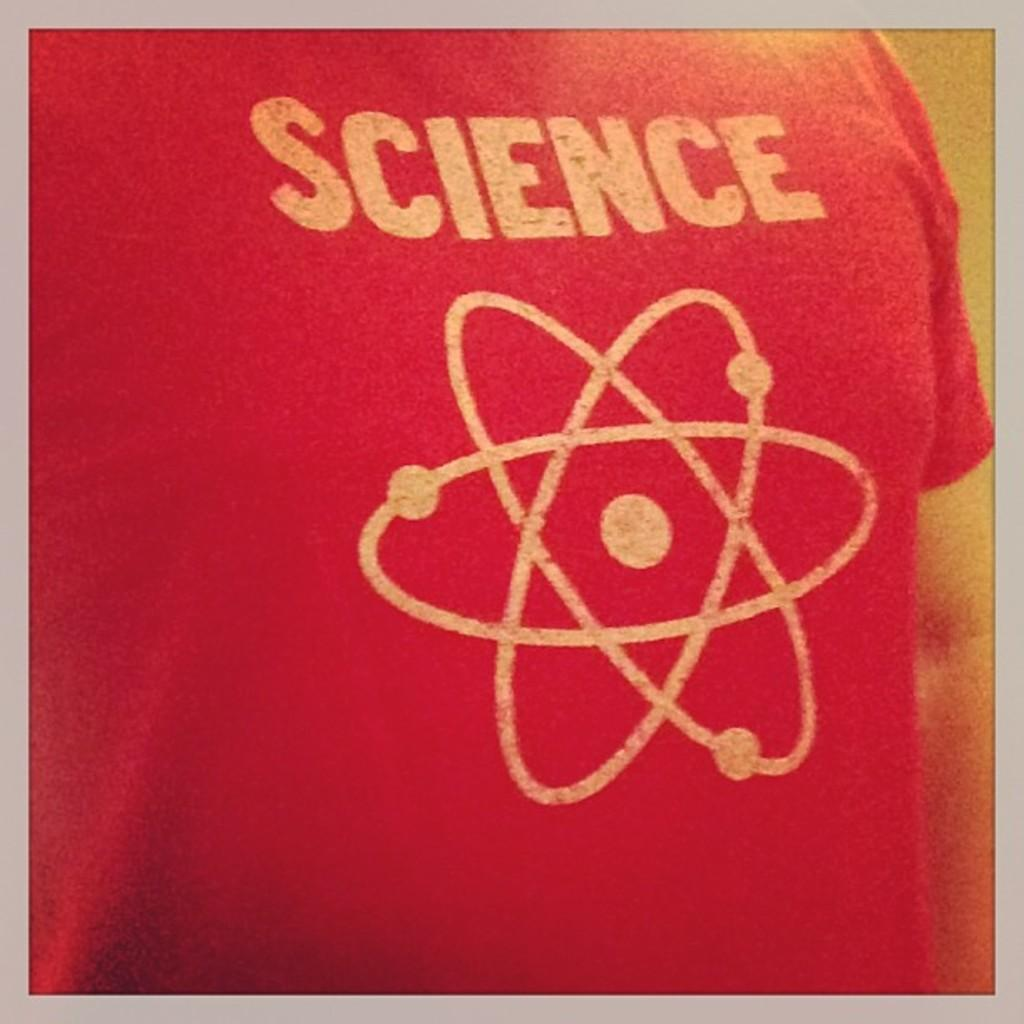<image>
Describe the image concisely. a shirt that has the word science on it 